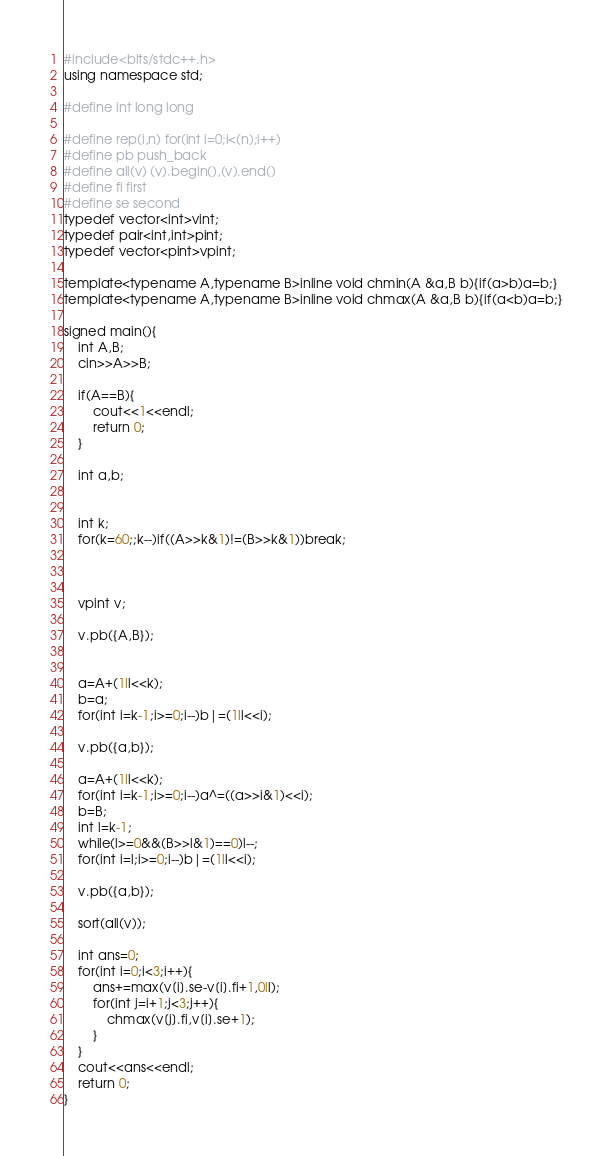Convert code to text. <code><loc_0><loc_0><loc_500><loc_500><_C++_>#include<bits/stdc++.h>
using namespace std;

#define int long long

#define rep(i,n) for(int i=0;i<(n);i++)
#define pb push_back
#define all(v) (v).begin(),(v).end()
#define fi first
#define se second
typedef vector<int>vint;
typedef pair<int,int>pint;
typedef vector<pint>vpint;

template<typename A,typename B>inline void chmin(A &a,B b){if(a>b)a=b;}
template<typename A,typename B>inline void chmax(A &a,B b){if(a<b)a=b;}

signed main(){
    int A,B;
    cin>>A>>B;

    if(A==B){
        cout<<1<<endl;
        return 0;
    }

    int a,b;


    int k;
    for(k=60;;k--)if((A>>k&1)!=(B>>k&1))break;



    vpint v;

    v.pb({A,B});


    a=A+(1ll<<k);
    b=a;
    for(int i=k-1;i>=0;i--)b|=(1ll<<i);

    v.pb({a,b});

    a=A+(1ll<<k);
    for(int i=k-1;i>=0;i--)a^=((a>>i&1)<<i);
    b=B;
    int l=k-1;
    while(l>=0&&(B>>l&1)==0)l--;
    for(int i=l;i>=0;i--)b|=(1ll<<i);

    v.pb({a,b});

    sort(all(v));

    int ans=0;
    for(int i=0;i<3;i++){
        ans+=max(v[i].se-v[i].fi+1,0ll);
        for(int j=i+1;j<3;j++){
            chmax(v[j].fi,v[i].se+1);
        }
    }
    cout<<ans<<endl;
    return 0;
}
</code> 